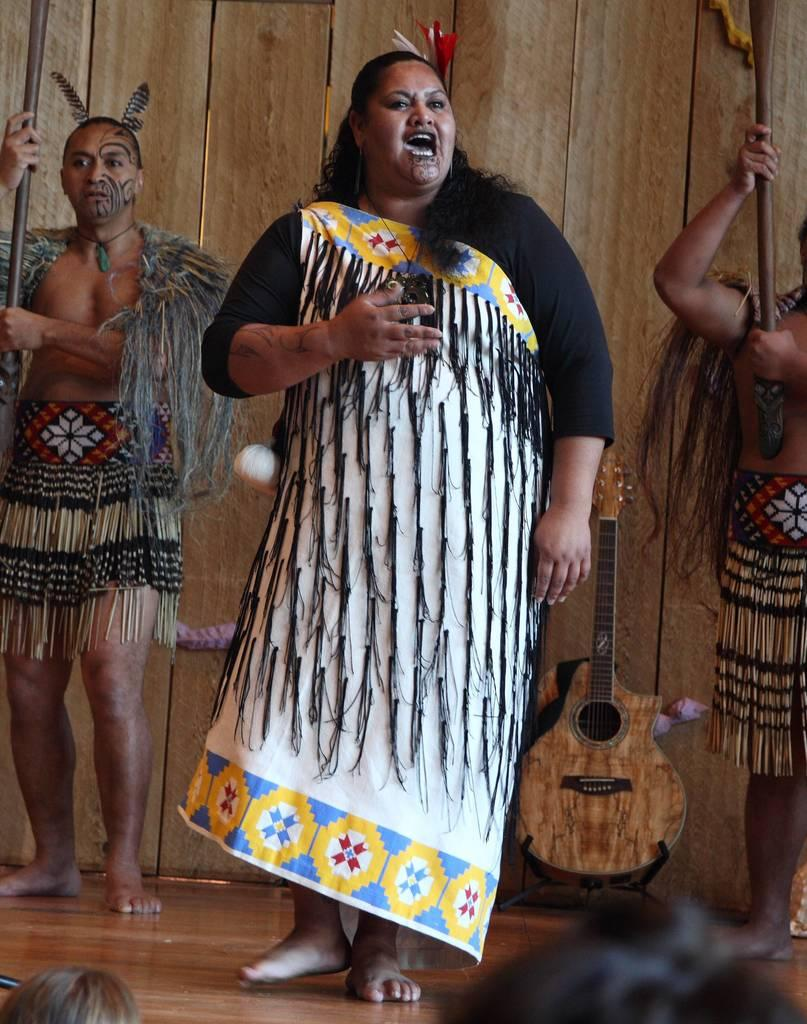How many people are in the image? There are three persons in the image. What are the persons doing in the image? The persons are standing and smiling. What can be seen in the background of the image? There is a wood wall and a guitar in the background of the image. What type of army apparel is visible on the persons in the image? There is no army apparel present in the image; the persons are not wearing any military clothing. What thing is being played by the persons in the image? There is no thing being played by the persons in the image; they are not depicted as playing any instruments or engaging in any activities. 